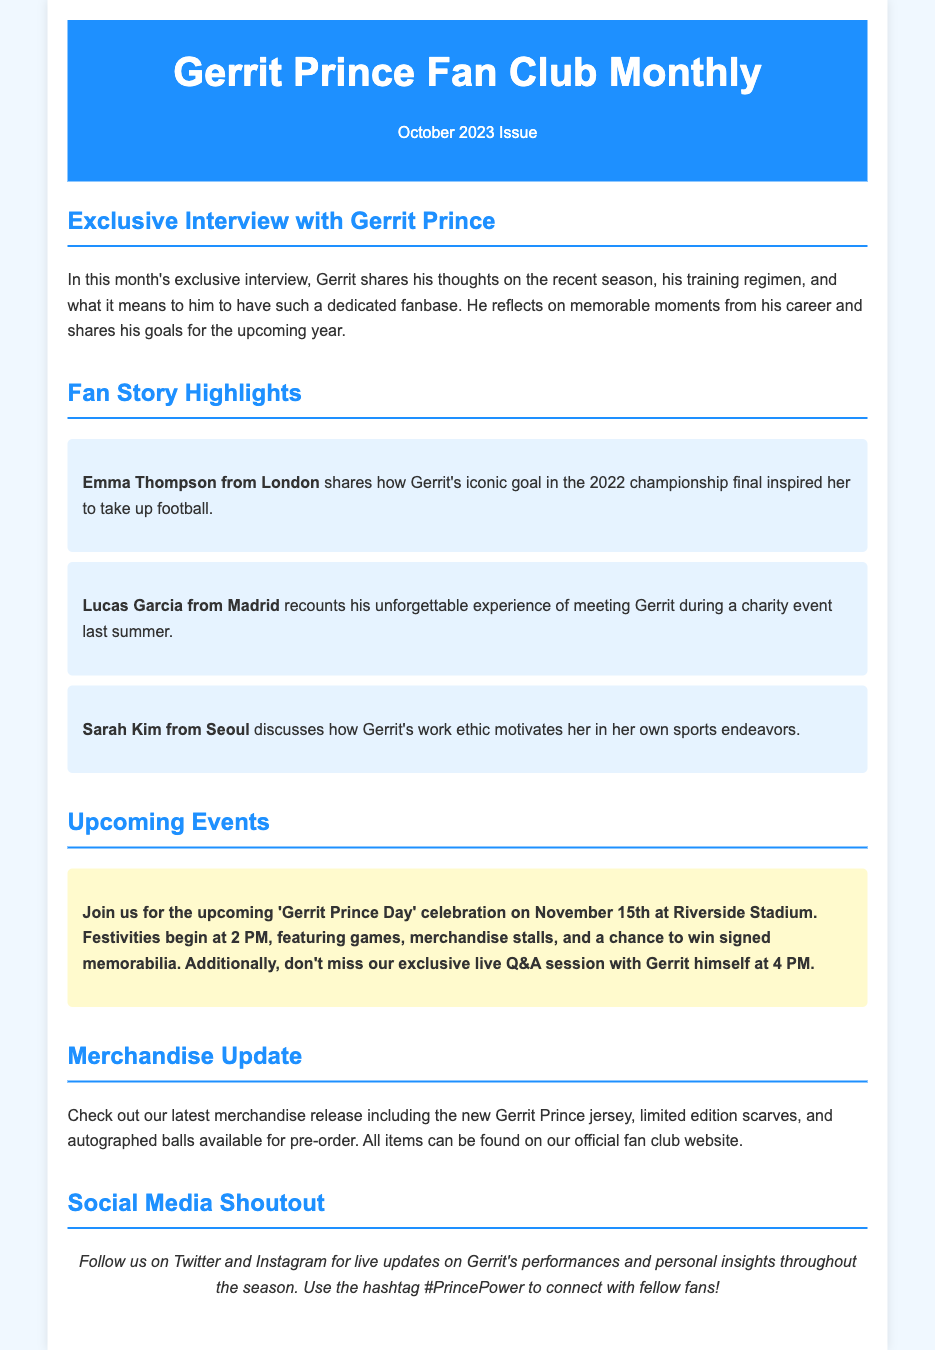What is the title of the newsletter? The title of the newsletter is featured prominently in the header section as the name of the fan club and the issue month.
Answer: Gerrit Prince Fan Club Monthly What date is the 'Gerrit Prince Day' celebration? The specific date for the celebration is mentioned in the upcoming events section of the document.
Answer: November 15th Who is the fan from London sharing her story? The fan story section includes names of fans along with their locations and personal anecdotes related to Gerrit Prince.
Answer: Emma Thompson What is featured in the exclusive interview with Gerrit Prince? The content of the interview is outlined in the section that mentions Gerrit's reflections on various topics related to his career.
Answer: Recent season, training regimen, dedicated fanbase What type of items are available for pre-order in the merchandise update? The merchandise update section lists the types of items that fans can pre-order related to Gerrit Prince.
Answer: Jerseys, scarves, autographed balls What hashtag can fans use to connect on social media? The social media shoutout section highlights the specific hashtag for fans to use while engaging online.
Answer: #PrincePower How many fan stories are highlighted in the newsletter? The fan story section lists individual stories provided by fans, counting the highlighted stories in the document.
Answer: Three What time does the live Q&A session with Gerrit take place? The upcoming events section specifies the time for the live Q&A session with Gerrit Prince during the celebration.
Answer: 4 PM 